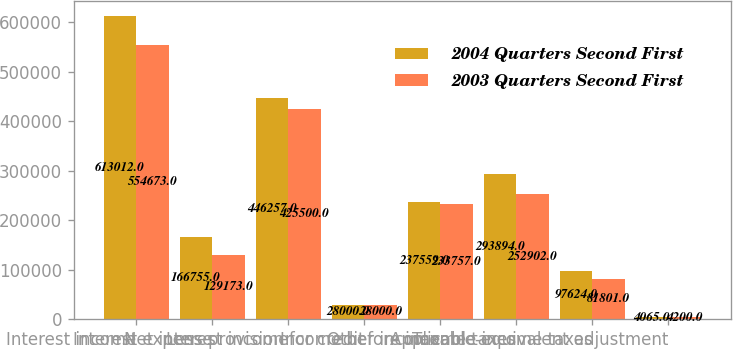<chart> <loc_0><loc_0><loc_500><loc_500><stacked_bar_chart><ecel><fcel>Interest income<fcel>Interest expense<fcel>Net interest income<fcel>Less provision for credit<fcel>Other income<fcel>Income before income taxes<fcel>Applicable income taxes<fcel>Taxable-equivalent adjustment<nl><fcel>2004 Quarters Second First<fcel>613012<fcel>166755<fcel>446257<fcel>28000<fcel>237559<fcel>293894<fcel>97624<fcel>4065<nl><fcel>2003 Quarters Second First<fcel>554673<fcel>129173<fcel>425500<fcel>28000<fcel>233757<fcel>252902<fcel>81801<fcel>4200<nl></chart> 